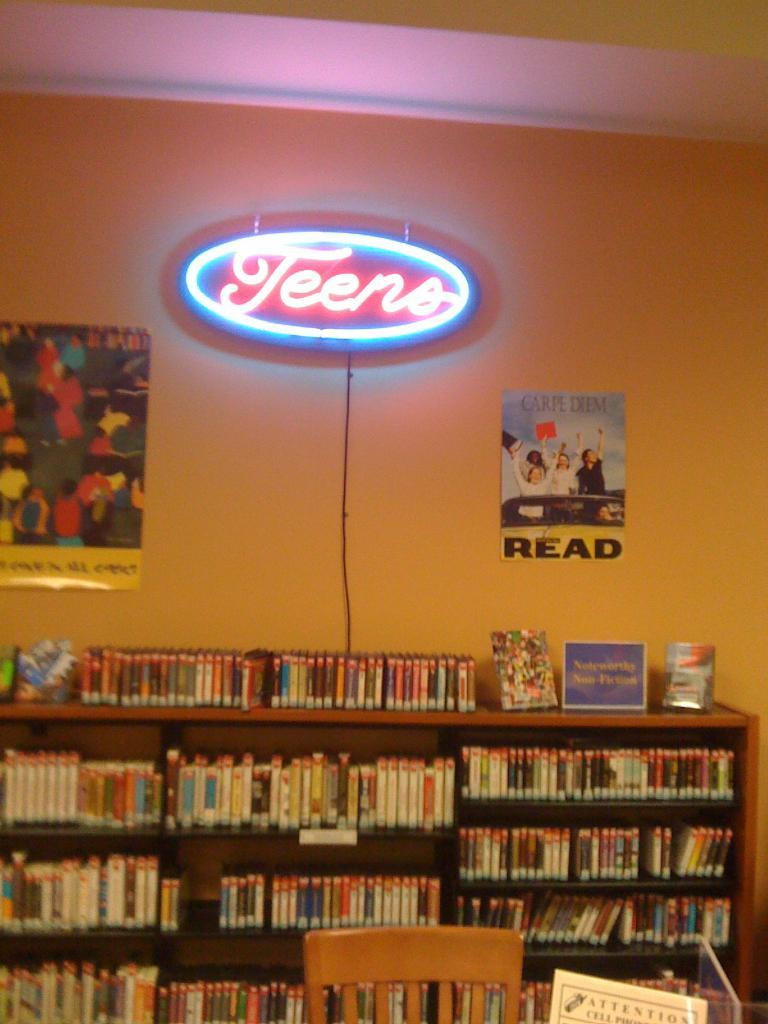What objects are present in the image? There are books in the image. Where are the books located? The books are kept on a shelf. What is on the wall behind the shelf? There is a banner on the wall behind the shelf. What does the banner say? The banner has the word "Teens" written on it. What type of lipstick is being used by the person in the image? There is no person present in the image, and therefore no lipstick or person using lipstick can be observed. 